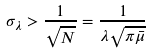<formula> <loc_0><loc_0><loc_500><loc_500>\sigma _ { \lambda } > \frac { 1 } { \sqrt { N } } = \frac { 1 } { \lambda \sqrt { \pi \bar { \mu } } }</formula> 